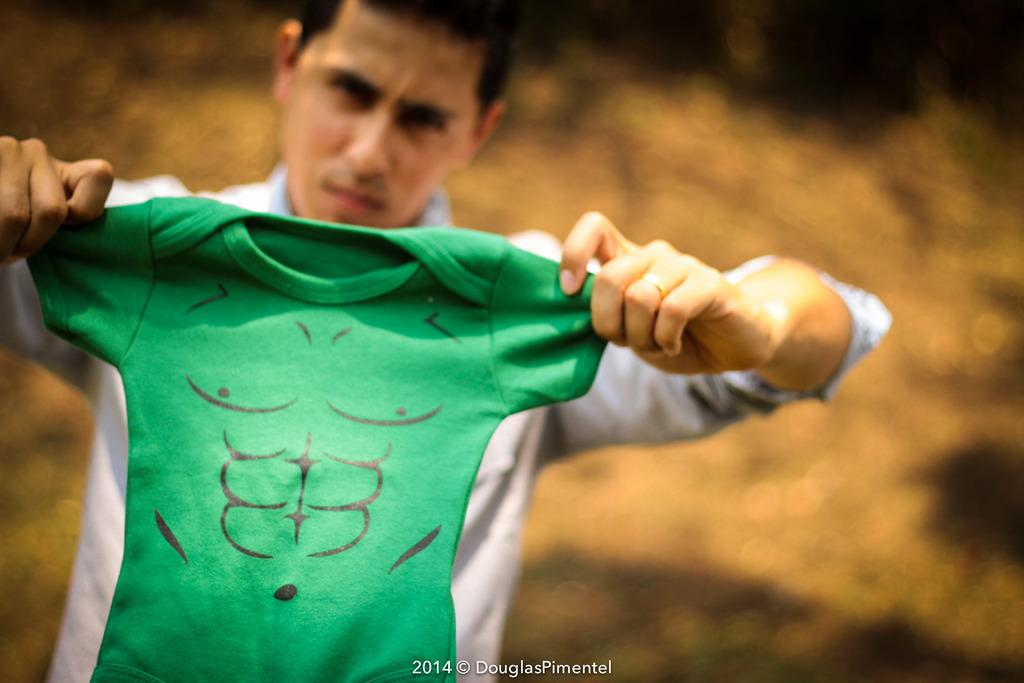What is the main subject of the image? There is a person in the image. What is the person holding in his hand? The person is holding a T-shirt in his hand. Is there any text present in the image? Yes, there is text at the bottom of the image. What type of space war is depicted in the image? There is no depiction of a space war in the image; it features a person holding a T-shirt with text at the bottom. What is the condition of the person's elbow in the image? The condition of the person's elbow is not mentioned or visible in the image. 